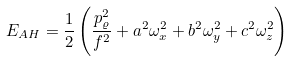<formula> <loc_0><loc_0><loc_500><loc_500>E _ { A H } = \frac { 1 } { 2 } \left ( \frac { p _ { \varrho } ^ { 2 } } { f ^ { 2 } } + a ^ { 2 } \omega _ { x } ^ { 2 } + b ^ { 2 } \omega _ { y } ^ { 2 } + c ^ { 2 } \omega _ { z } ^ { 2 } \right )</formula> 